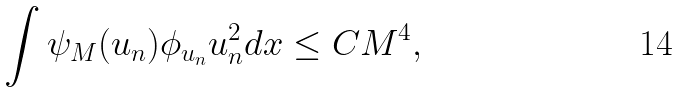Convert formula to latex. <formula><loc_0><loc_0><loc_500><loc_500>\int \psi _ { M } ( u _ { n } ) \phi _ { u _ { n } } u _ { n } ^ { 2 } d x \leq C M ^ { 4 } ,</formula> 